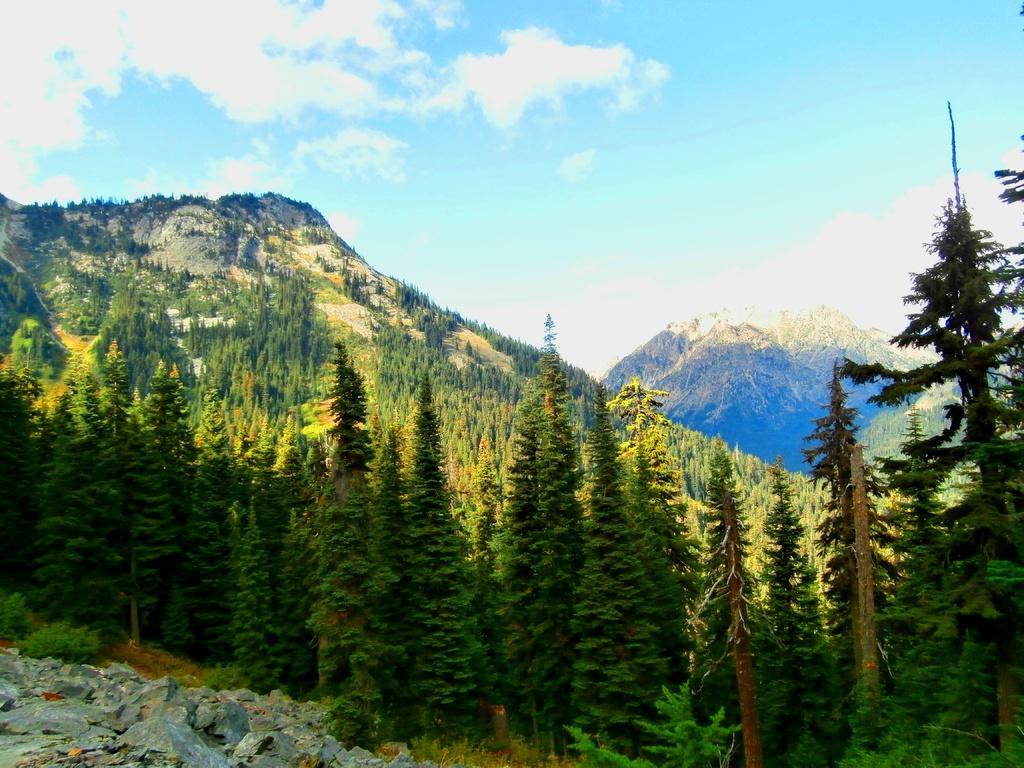Please provide a concise description of this image. These are the stones. There are many Christmas trees on a mountain and the sky is in blue color with clouds. 